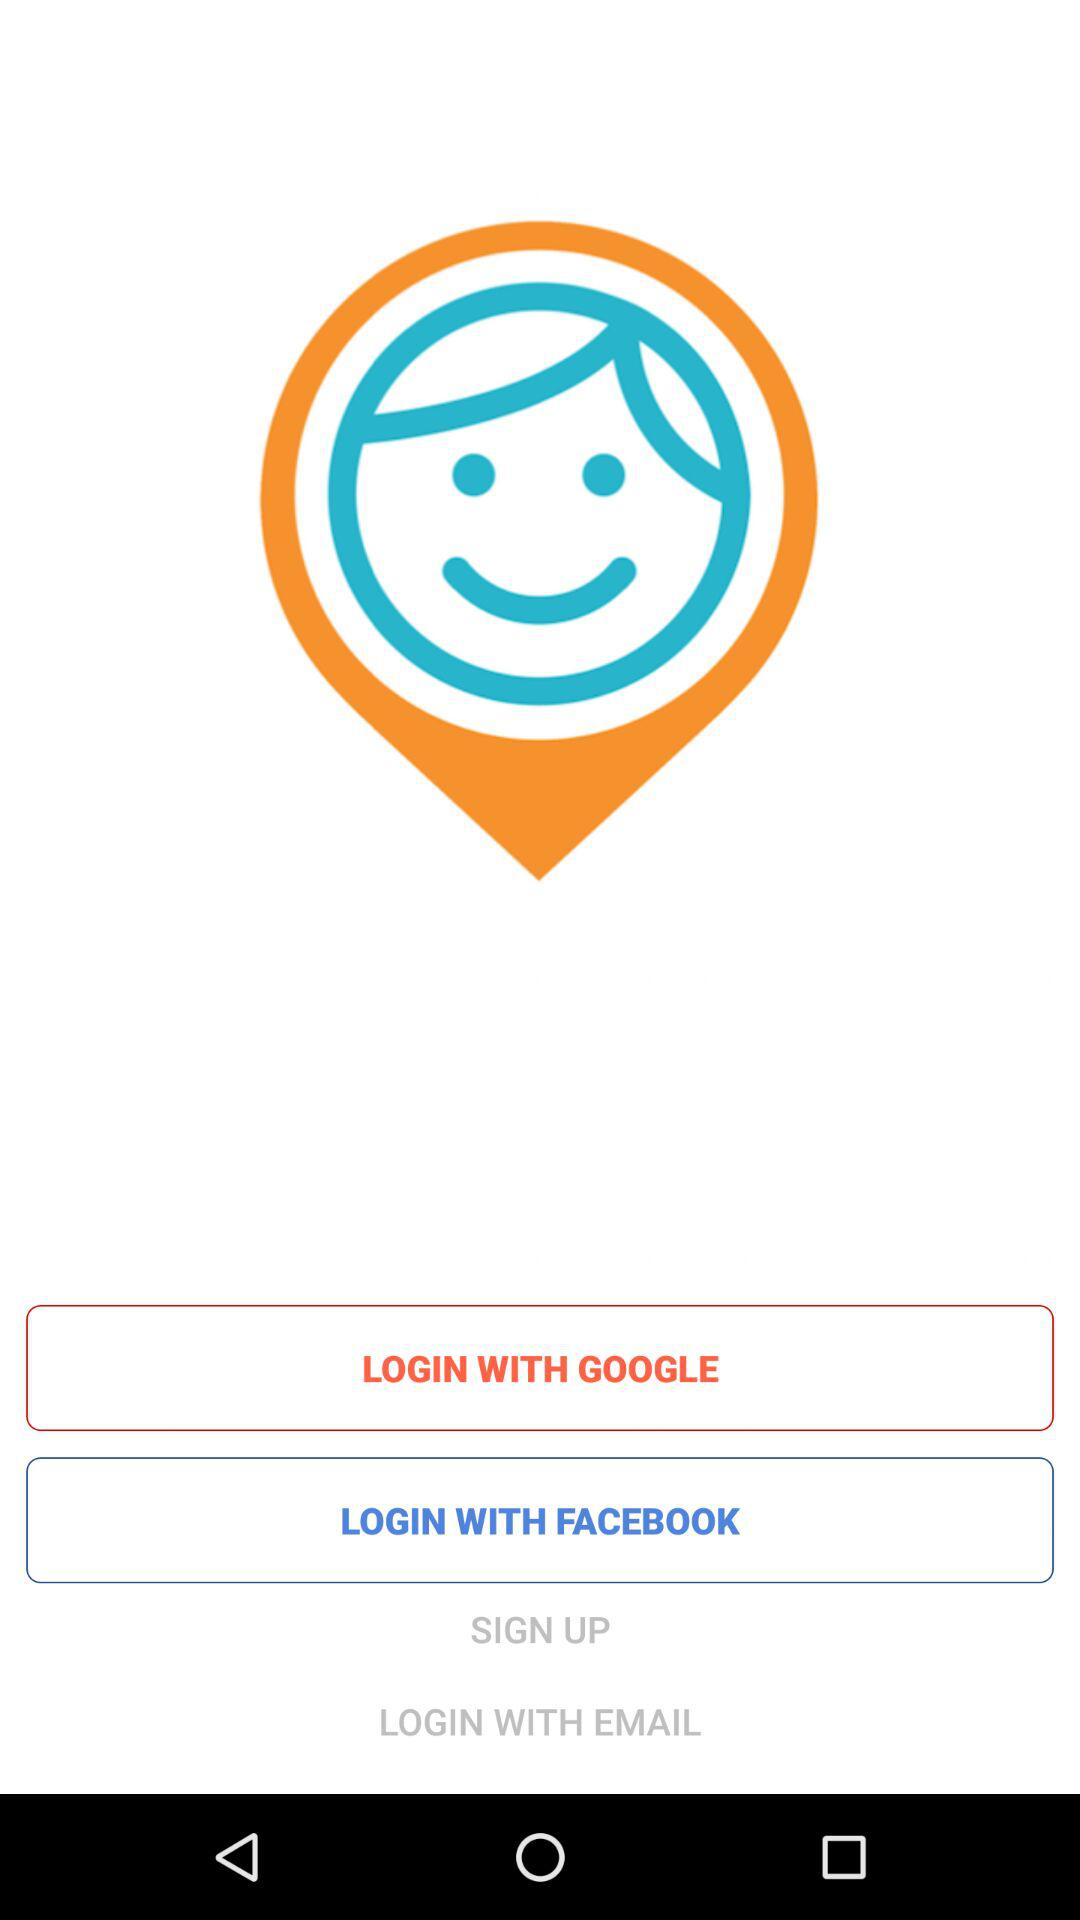What are the login options? The login options are: "GOOGLE", "FACEBOOK", and "EMAIL". 